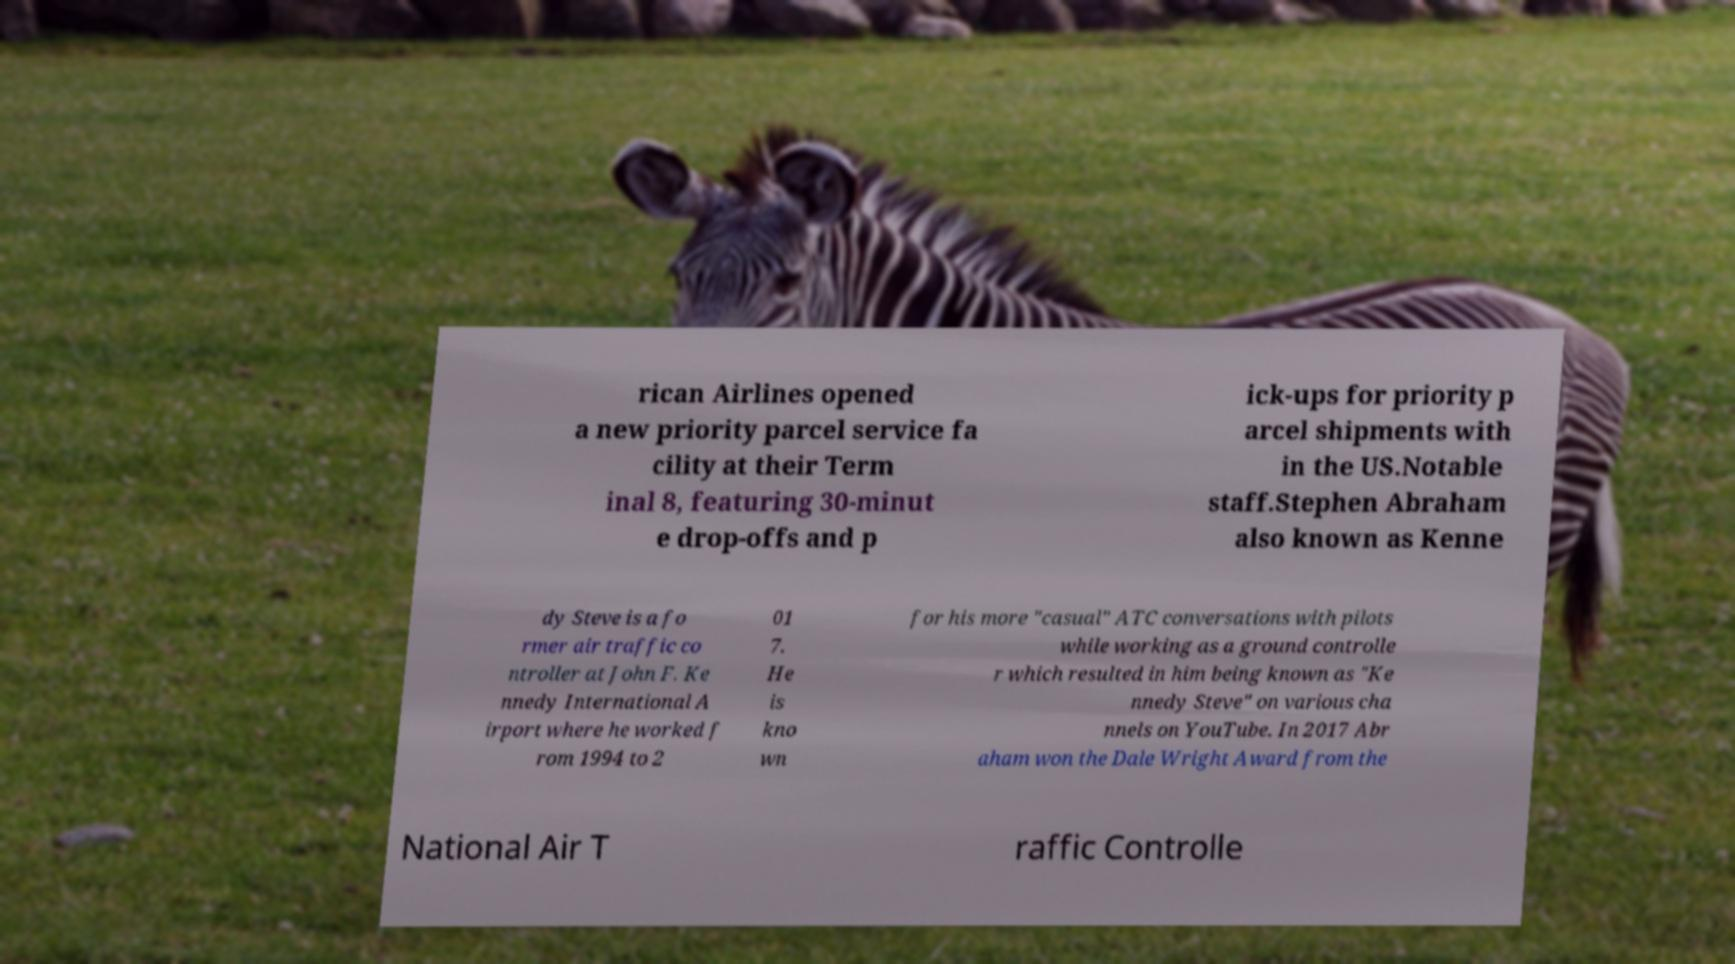Can you accurately transcribe the text from the provided image for me? rican Airlines opened a new priority parcel service fa cility at their Term inal 8, featuring 30-minut e drop-offs and p ick-ups for priority p arcel shipments with in the US.Notable staff.Stephen Abraham also known as Kenne dy Steve is a fo rmer air traffic co ntroller at John F. Ke nnedy International A irport where he worked f rom 1994 to 2 01 7. He is kno wn for his more "casual" ATC conversations with pilots while working as a ground controlle r which resulted in him being known as "Ke nnedy Steve" on various cha nnels on YouTube. In 2017 Abr aham won the Dale Wright Award from the National Air T raffic Controlle 